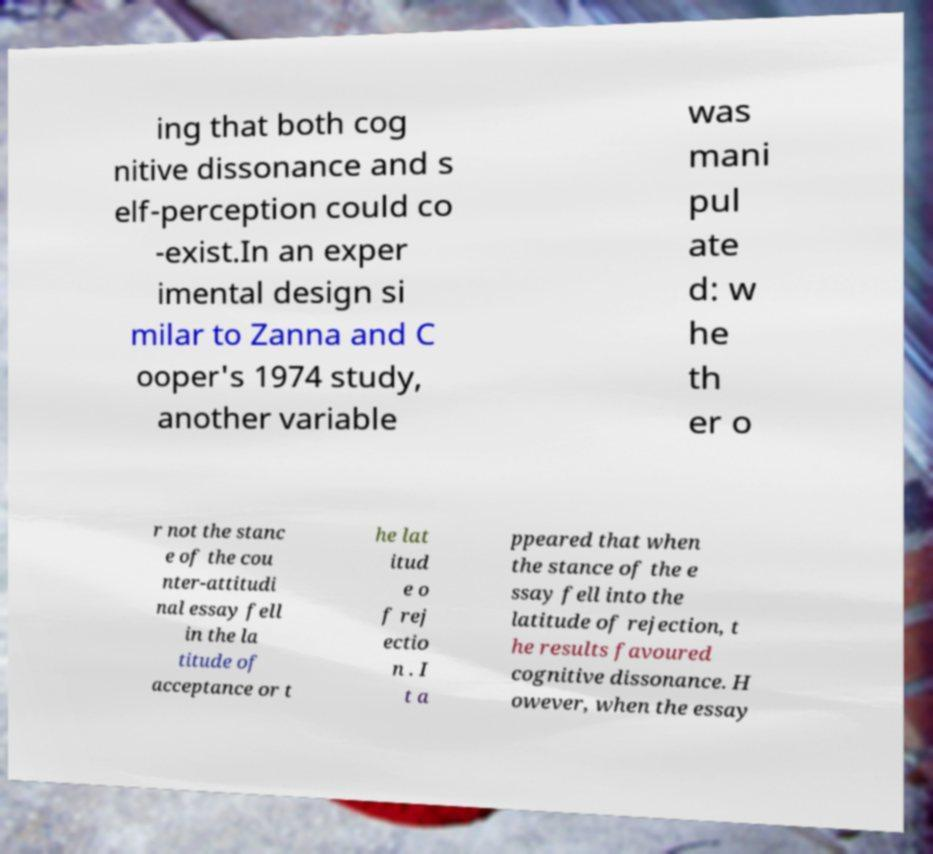Please read and relay the text visible in this image. What does it say? ing that both cog nitive dissonance and s elf-perception could co -exist.In an exper imental design si milar to Zanna and C ooper's 1974 study, another variable was mani pul ate d: w he th er o r not the stanc e of the cou nter-attitudi nal essay fell in the la titude of acceptance or t he lat itud e o f rej ectio n . I t a ppeared that when the stance of the e ssay fell into the latitude of rejection, t he results favoured cognitive dissonance. H owever, when the essay 